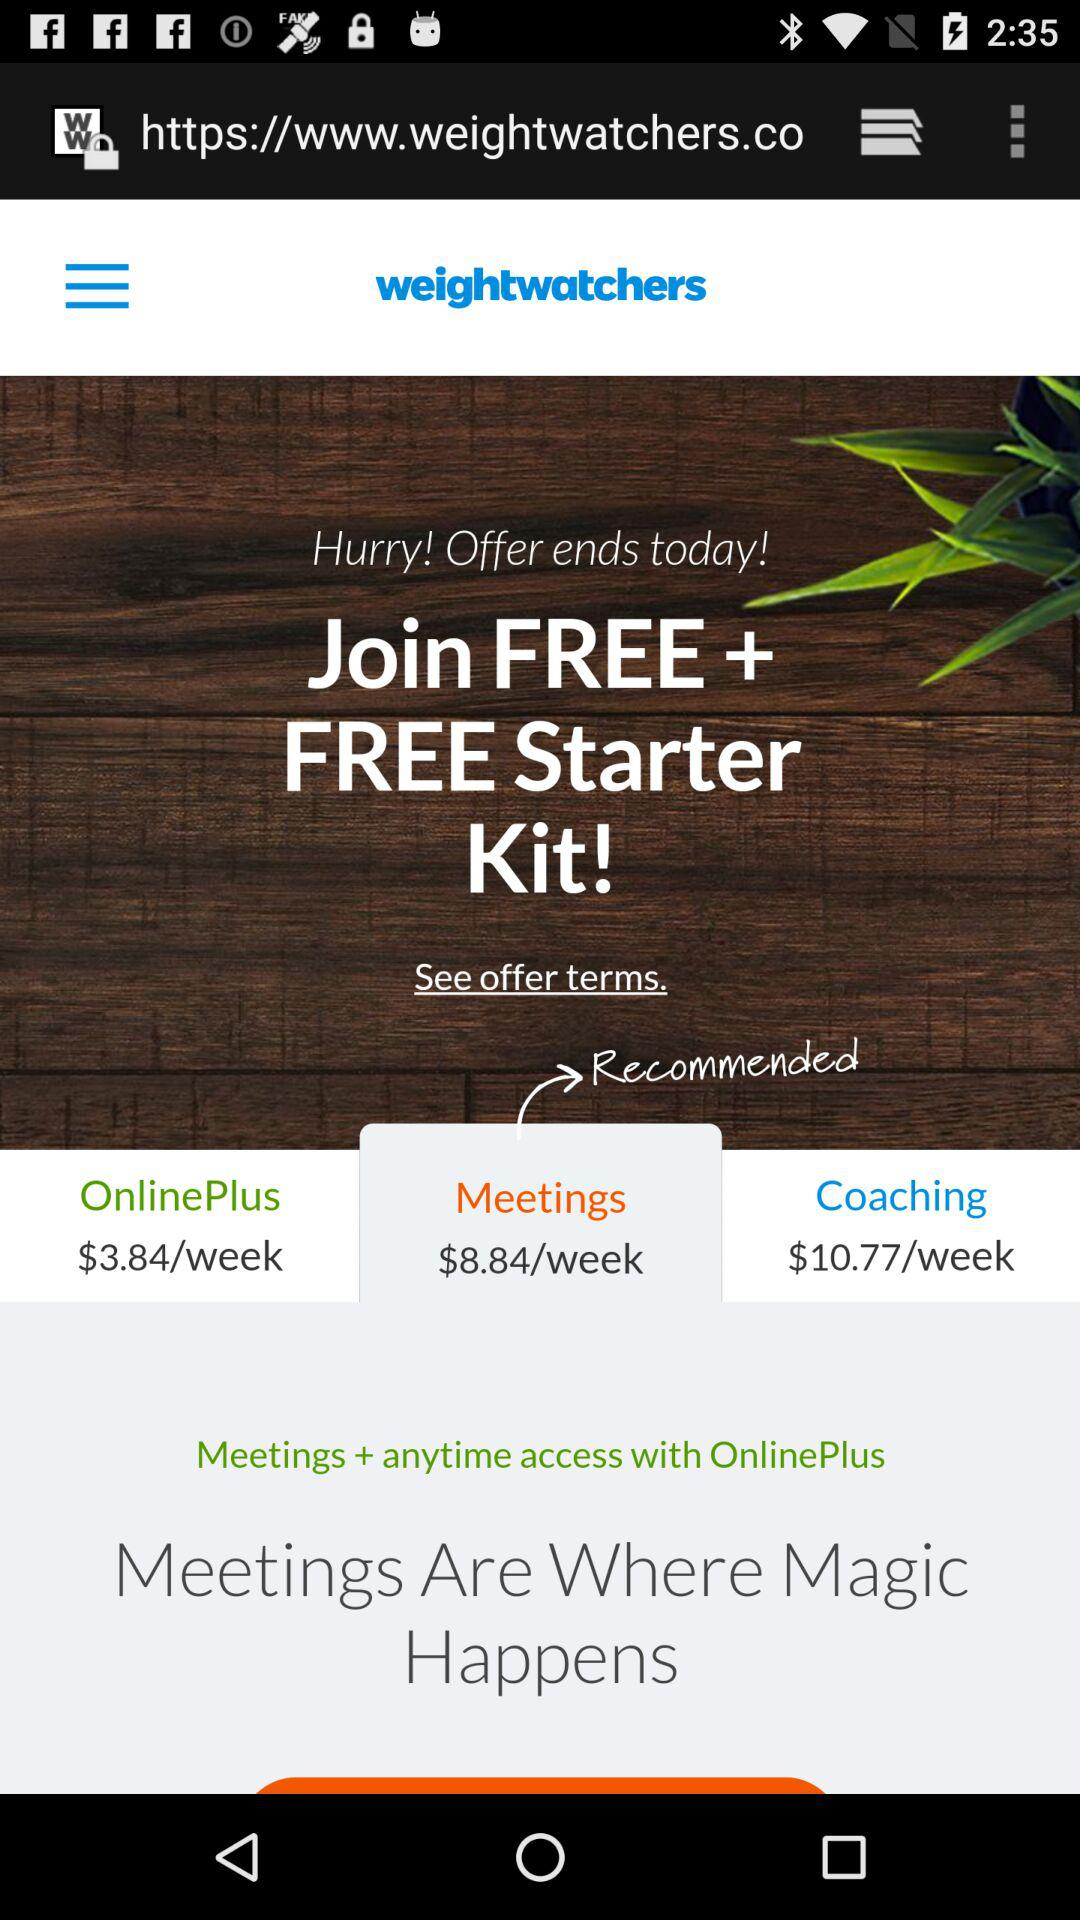Which tab is selected? The selected tab is "Meetings $8.84/week". 